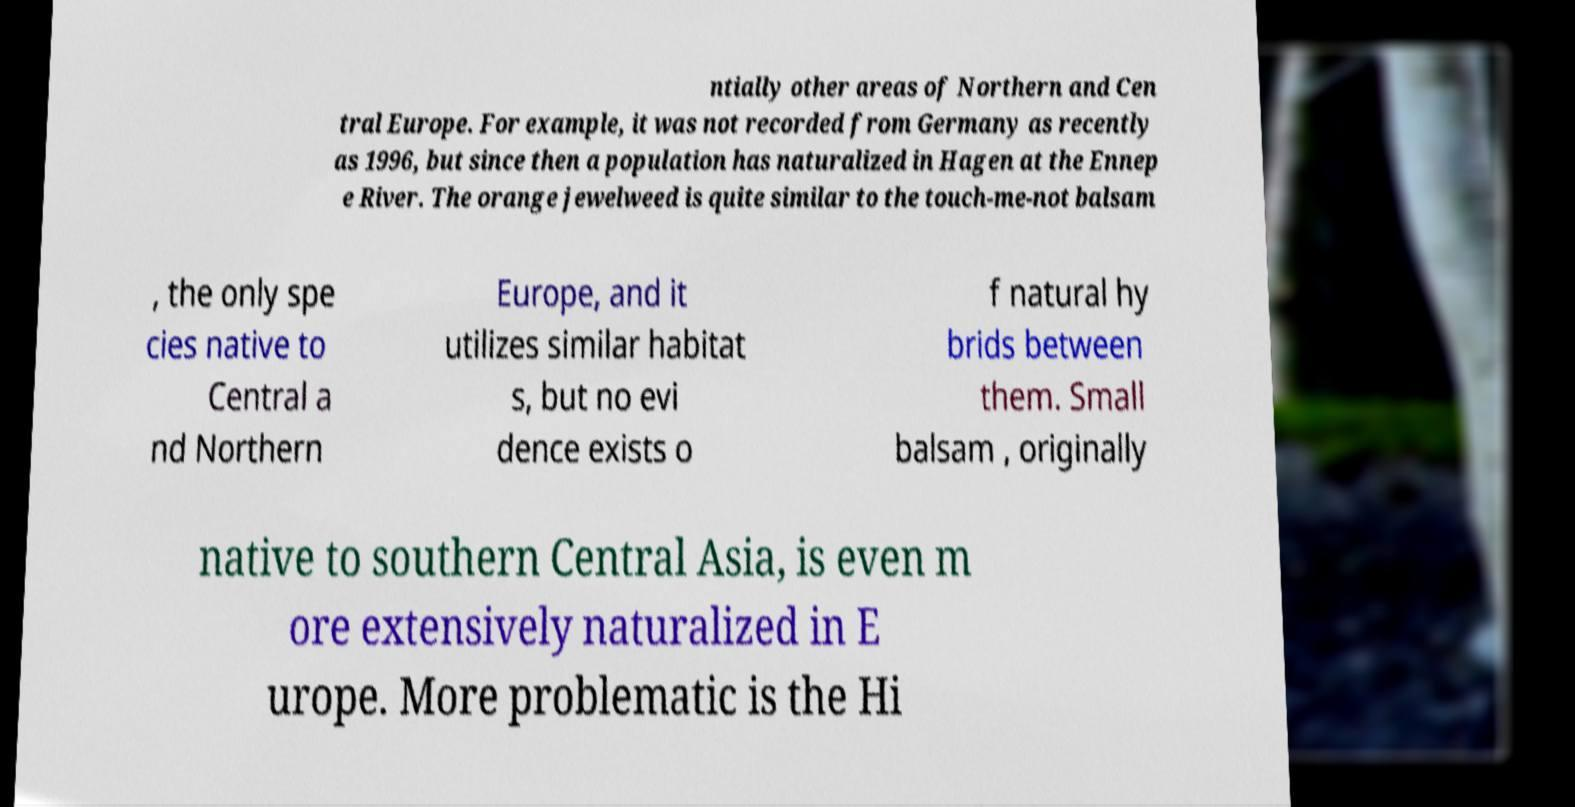There's text embedded in this image that I need extracted. Can you transcribe it verbatim? ntially other areas of Northern and Cen tral Europe. For example, it was not recorded from Germany as recently as 1996, but since then a population has naturalized in Hagen at the Ennep e River. The orange jewelweed is quite similar to the touch-me-not balsam , the only spe cies native to Central a nd Northern Europe, and it utilizes similar habitat s, but no evi dence exists o f natural hy brids between them. Small balsam , originally native to southern Central Asia, is even m ore extensively naturalized in E urope. More problematic is the Hi 